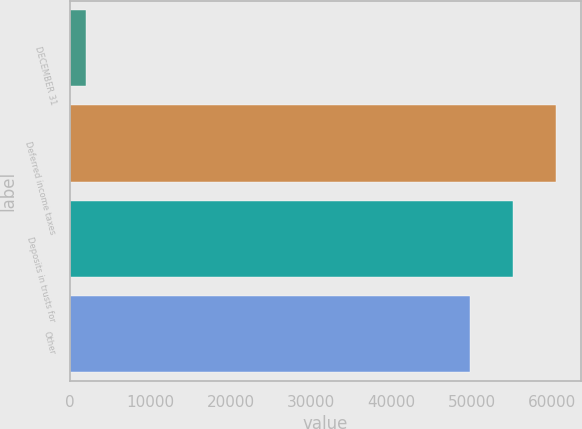Convert chart. <chart><loc_0><loc_0><loc_500><loc_500><bar_chart><fcel>DECEMBER 31<fcel>Deferred income taxes<fcel>Deposits in trusts for<fcel>Other<nl><fcel>2007<fcel>60471<fcel>55119.5<fcel>49768<nl></chart> 